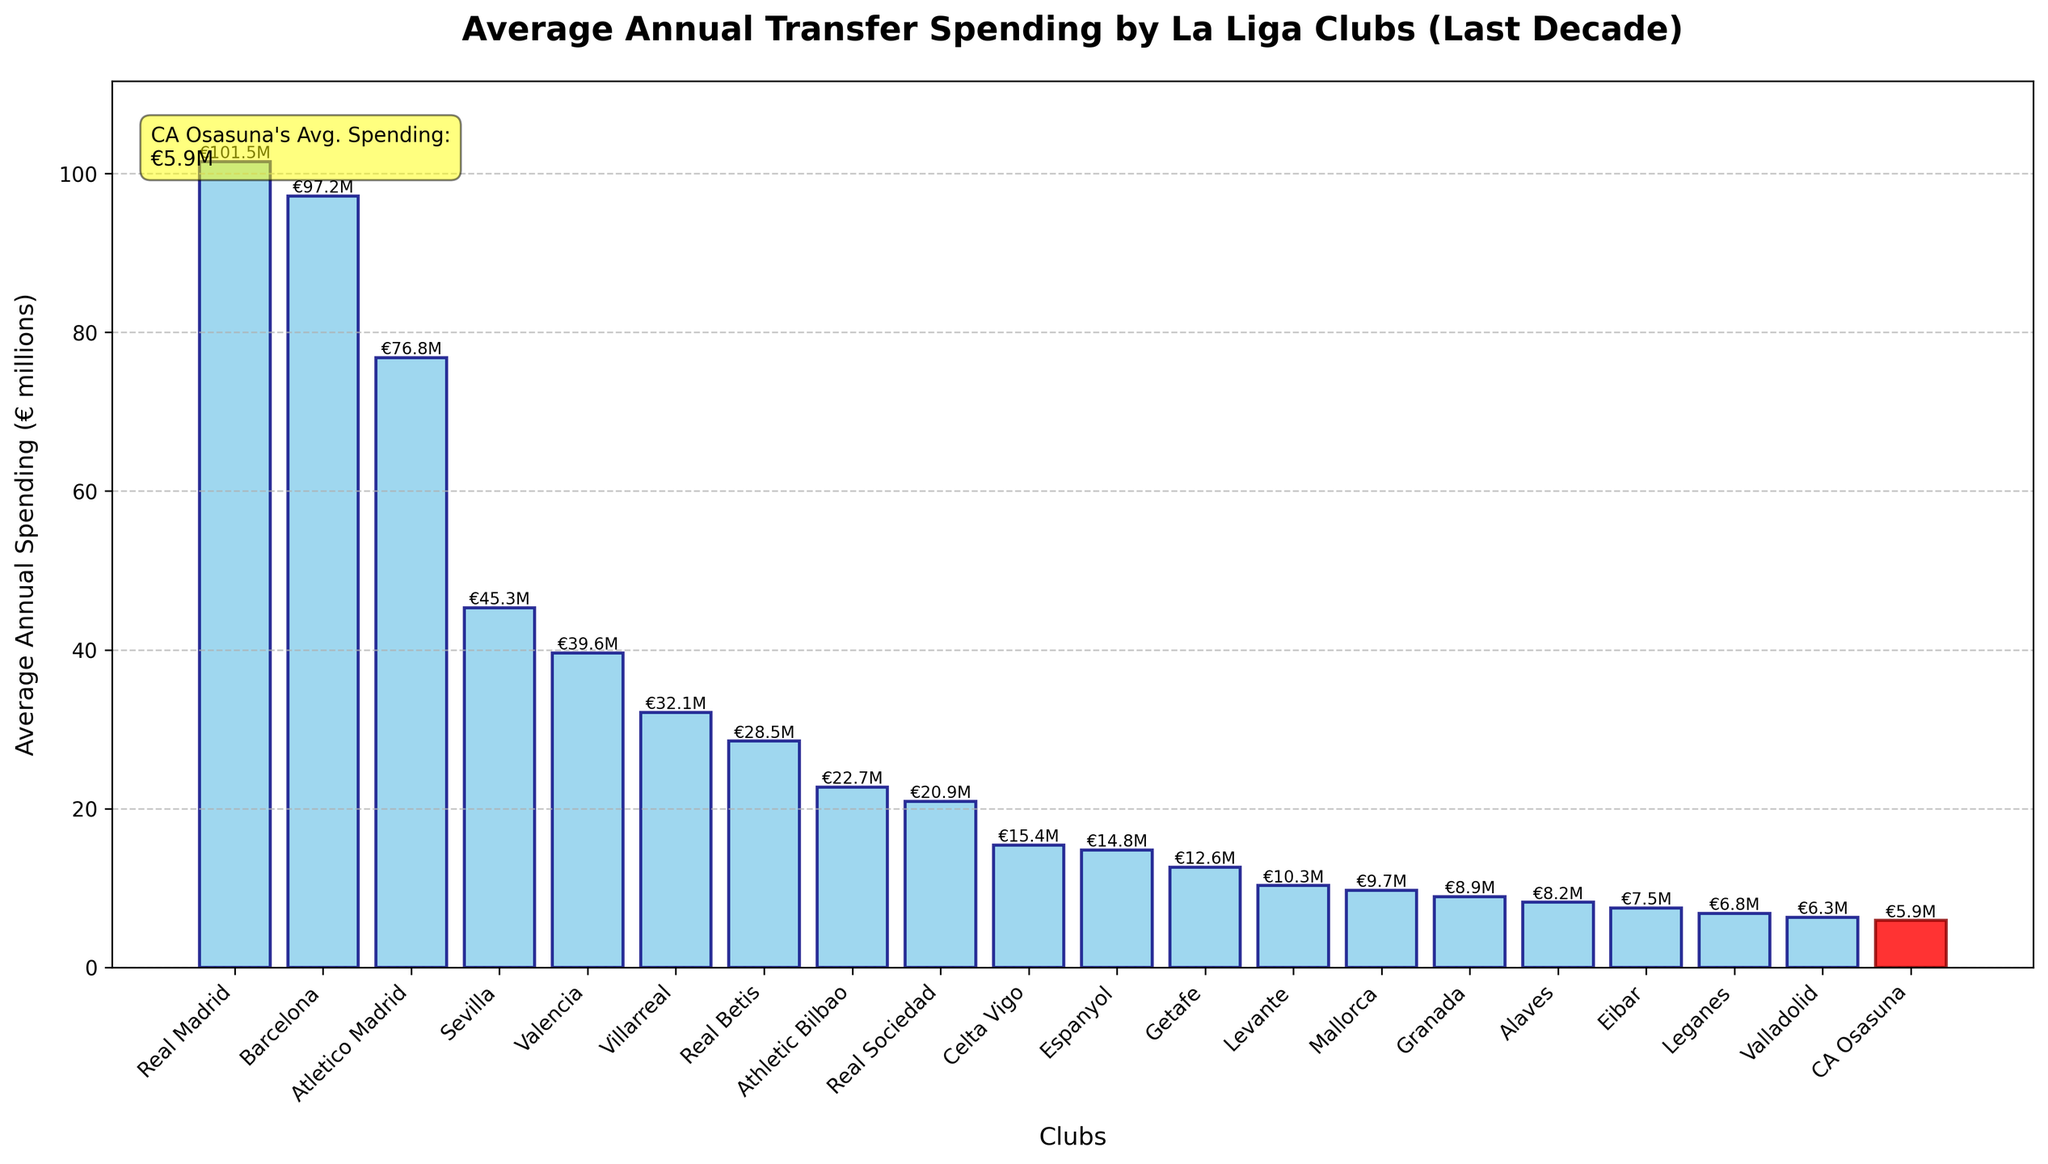What's the average annual transfer spending of CA Osasuna? The highlighted red bar represents CA Osasuna's spending. The label on the bar indicates average annual spending is €5.9 million.
Answer: €5.9 million Which club has the highest average annual transfer spending? The tallest bar in the chart belongs to Real Madrid, as the height of the bar represents the highest value. The label on the bar reads €101.5 million.
Answer: Real Madrid How does CA Osasuna's spending compare to Real Madrid's spending? CA Osasuna's bar is significantly shorter and has an average spending of €5.9 million, while Real Madrid's bar is the tallest with €101.5 million. The latter spends much more, roughly 17 times as much.
Answer: Real Madrid spends much more What's the average of the bottom three clubs in terms of average annual transfer spending? Identify the three shortest bars from the graph, which belong to Valladolid (€6.3 million), Leganes (€6.8 million), and CA Osasuna (€5.9 million). Calculate the average: (6.3 + 6.8 + 5.9) / 3 = 19 / 3 = 6.33.
Answer: €6.33 million Which clubs have an average annual transfer spending greater than €50 million? Identify the bars taller than the €50 million mark, which are Real Madrid (€101.5 million), Barcelona (€97.2 million), and Atletico Madrid (€76.8 million).
Answer: Real Madrid, Barcelona, Atletico Madrid Is CA Osasuna's spending higher or lower than Espanyol's average annual transfer spending? The red bar for CA Osasuna (€5.9 million) is shorter than Espanyol's bar (€14.8 million). Hence, CA Osasuna's spending is lower.
Answer: Lower What is the combined average annual transfer spending of the top 5 clubs? Identify the top 5 bars, representing Real Madrid, Barcelona, Atletico Madrid, Sevilla, and Valencia. Sum the values: 101.5 + 97.2 + 76.8 + 45.3 + 39.6 = 360.4 million.
Answer: €360.4 million How many clubs have an average annual transfer spending between €20 million and €30 million? Count the bars with heights corresponding to values between €20 million and €30 million: Athletic Bilbao (€22.7 million), Real Sociedad (€20.9 million), Real Betis (€28.5 million).
Answer: Three clubs What is the difference in average annual transfer spending between CA Osasuna and Villarreal? Subtract Osasuna's spending from Villarreal's: 32.1 - 5.9 = 26.2 million.
Answer: €26.2 million Which club is just above CA Osasuna in terms of average annual transfer spending? Observing the graph, the club with the next higher bar above Osasuna is Valladolid (€6.3 million).
Answer: Valladolid 